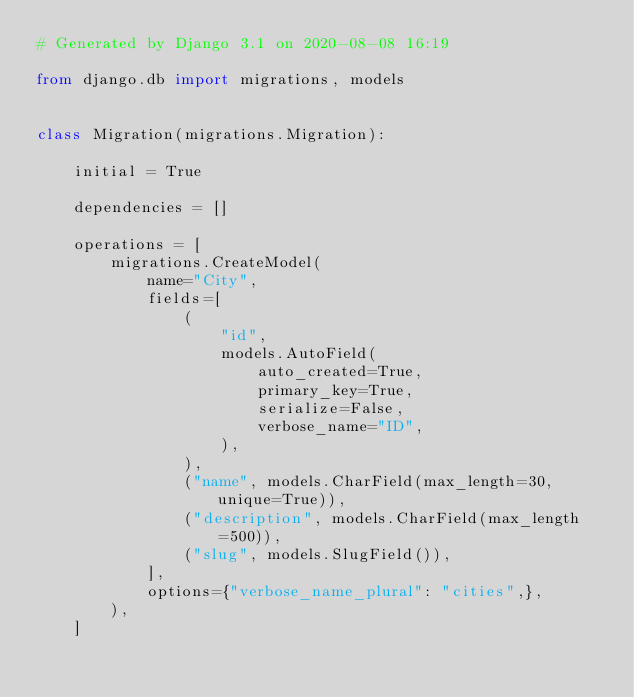<code> <loc_0><loc_0><loc_500><loc_500><_Python_># Generated by Django 3.1 on 2020-08-08 16:19

from django.db import migrations, models


class Migration(migrations.Migration):

    initial = True

    dependencies = []

    operations = [
        migrations.CreateModel(
            name="City",
            fields=[
                (
                    "id",
                    models.AutoField(
                        auto_created=True,
                        primary_key=True,
                        serialize=False,
                        verbose_name="ID",
                    ),
                ),
                ("name", models.CharField(max_length=30, unique=True)),
                ("description", models.CharField(max_length=500)),
                ("slug", models.SlugField()),
            ],
            options={"verbose_name_plural": "cities",},
        ),
    ]
</code> 